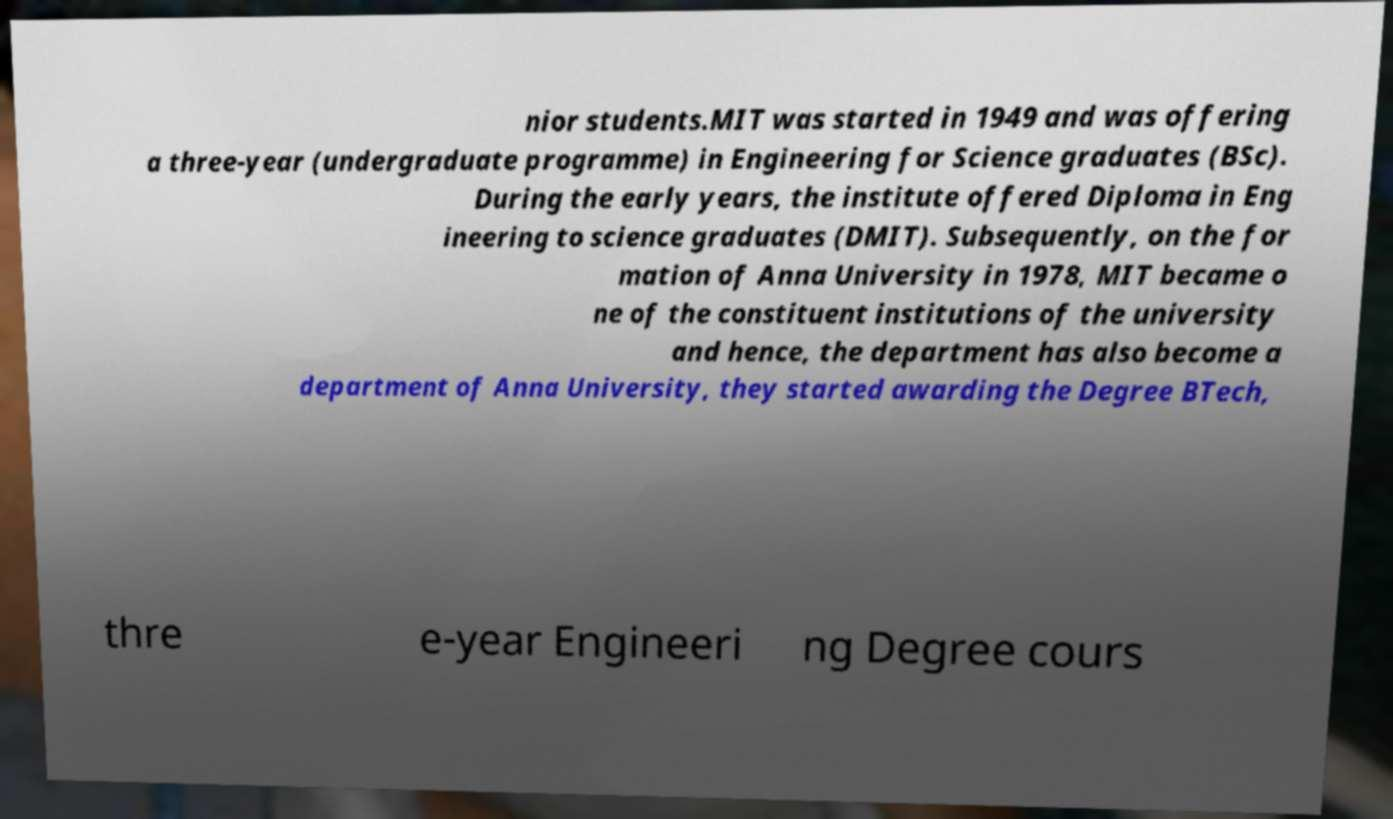Could you extract and type out the text from this image? nior students.MIT was started in 1949 and was offering a three-year (undergraduate programme) in Engineering for Science graduates (BSc). During the early years, the institute offered Diploma in Eng ineering to science graduates (DMIT). Subsequently, on the for mation of Anna University in 1978, MIT became o ne of the constituent institutions of the university and hence, the department has also become a department of Anna University, they started awarding the Degree BTech, thre e-year Engineeri ng Degree cours 